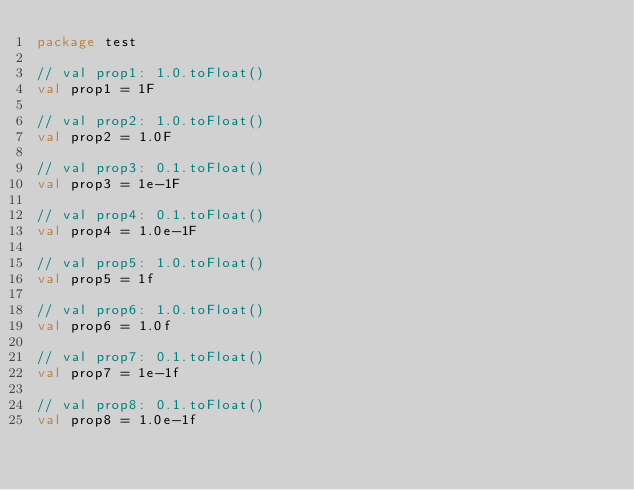Convert code to text. <code><loc_0><loc_0><loc_500><loc_500><_Kotlin_>package test

// val prop1: 1.0.toFloat()
val prop1 = 1F

// val prop2: 1.0.toFloat()
val prop2 = 1.0F

// val prop3: 0.1.toFloat()
val prop3 = 1e-1F

// val prop4: 0.1.toFloat()
val prop4 = 1.0e-1F

// val prop5: 1.0.toFloat()
val prop5 = 1f

// val prop6: 1.0.toFloat()
val prop6 = 1.0f

// val prop7: 0.1.toFloat()
val prop7 = 1e-1f

// val prop8: 0.1.toFloat()
val prop8 = 1.0e-1f
</code> 